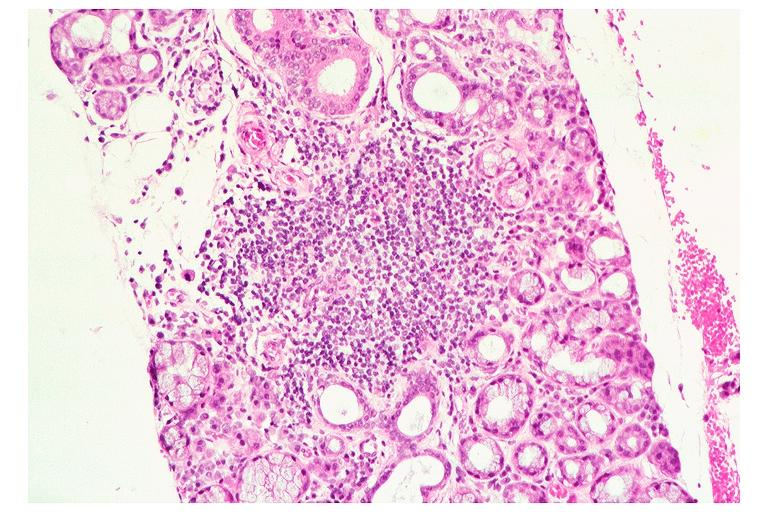s this lesion present?
Answer the question using a single word or phrase. No 